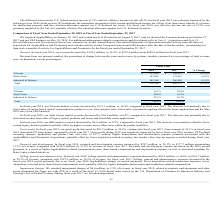According to Macom Technology's financial document, What led to decrease in I&D market revenues? lower certain legacy defense products partially offset by higher revenue across other areas within the product portfolio.. The document states: "l year 2017. The decrease was primarily related to lower certain legacy defense products partially offset by higher revenue across other areas within ..." Also, can you calculate: What is the change in Telecom value between fiscal year 2017 and 2018? Based on the calculation: 222,940-340,022, the result is -117082 (in thousands). This is based on the information: "Telecom $ 222,940 $ 340,022 (34.4)% Telecom $ 222,940 $ 340,022 (34.4)%..." The key data points involved are: 222,940, 340,022. Also, can you calculate: What is the average Telecom value for fiscal year 2017 and 2018? To answer this question, I need to perform calculations using the financial data. The calculation is: (222,940+340,022) / 2, which equals 281481 (in thousands). This is based on the information: "Telecom $ 222,940 $ 340,022 (34.4)% Telecom $ 222,940 $ 340,022 (34.4)%..." The key data points involved are: 222,940, 340,022. Additionally, In which year was Telecom value less than 300,000 thousand? According to the financial document, 2018. The relevant text states: "2018 2017 % Change..." Also, What was the respective value of Data Center in 2019 and 2018? The document shows two values: 162,098 and 172,481 (in thousands). From the document: "Data Center 162,098 172,481 (6.0)% Data Center 162,098 172,481 (6.0)%..." Also, When was AppliedMicro acquired? According to the financial document, January 26, 2017. The relevant text states: "We acquired AppliedMicro on January 26, 2017 and certain assets of Picometrix on August 9, 2017, and we divested the Compute business on October..." 